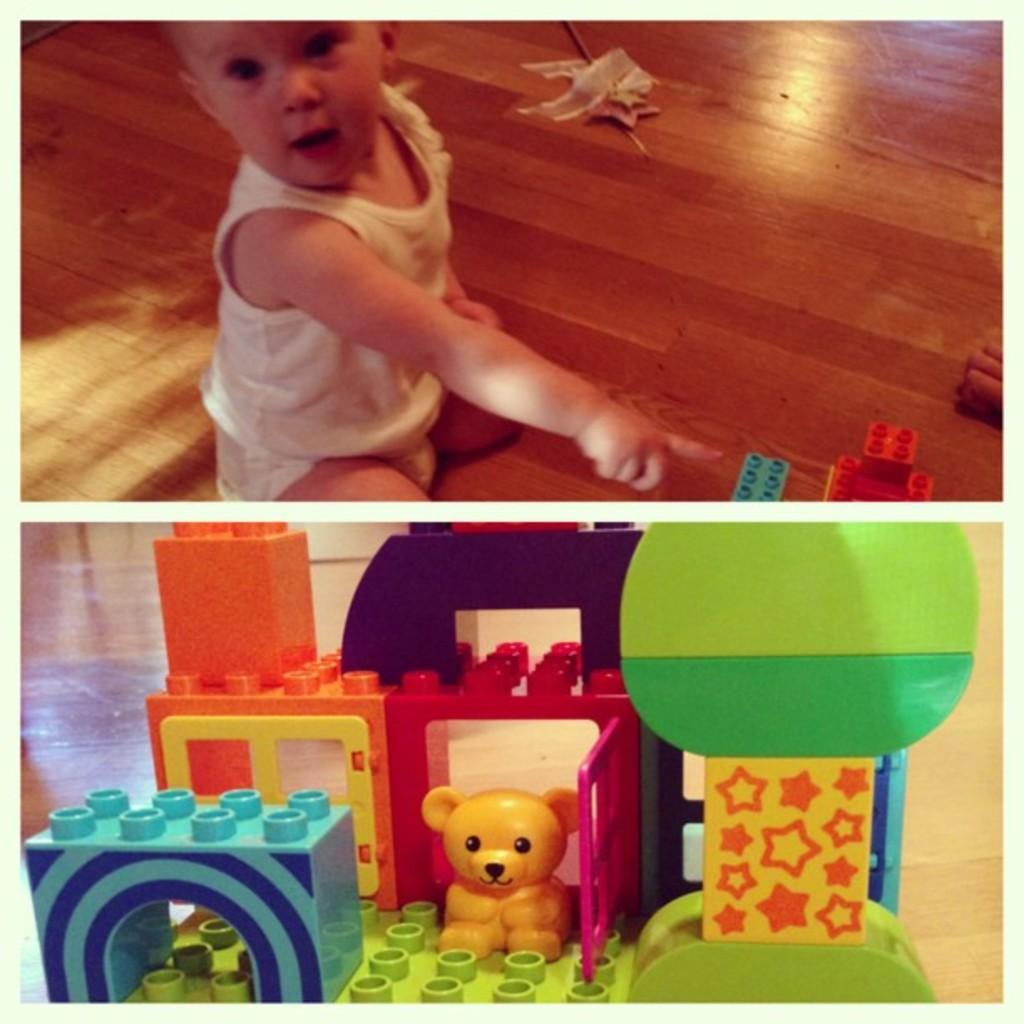What is the composition of the image? The image is a collage of two pictures. What can be seen in the first picture? In the first picture, a boy is wearing a dress. What is depicted in the second picture? The second picture shows a group of Lego toys placed on the ground. What type of arm is visible in the image? There is no arm present in the image; it features a boy wearing a dress and a group of Lego toys. How many nails can be seen in the image? There are no nails visible in the image. 